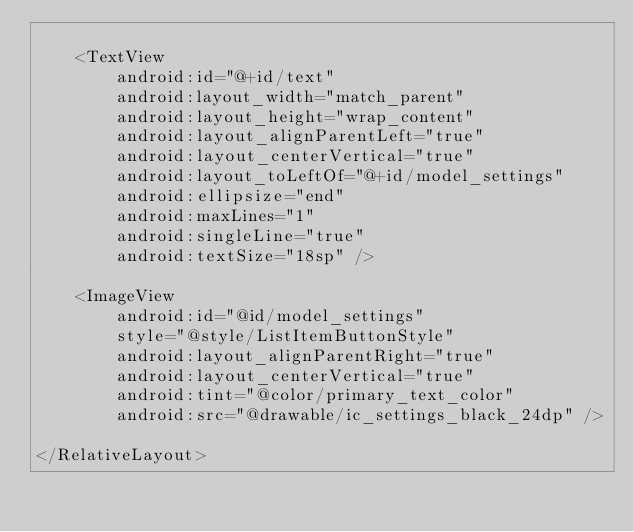Convert code to text. <code><loc_0><loc_0><loc_500><loc_500><_XML_>
    <TextView
        android:id="@+id/text"
        android:layout_width="match_parent"
        android:layout_height="wrap_content"
        android:layout_alignParentLeft="true"
        android:layout_centerVertical="true"
        android:layout_toLeftOf="@+id/model_settings"
        android:ellipsize="end"
        android:maxLines="1"
        android:singleLine="true"
        android:textSize="18sp" />

    <ImageView
        android:id="@id/model_settings"
        style="@style/ListItemButtonStyle"
        android:layout_alignParentRight="true"
        android:layout_centerVertical="true"
        android:tint="@color/primary_text_color"
        android:src="@drawable/ic_settings_black_24dp" />

</RelativeLayout></code> 